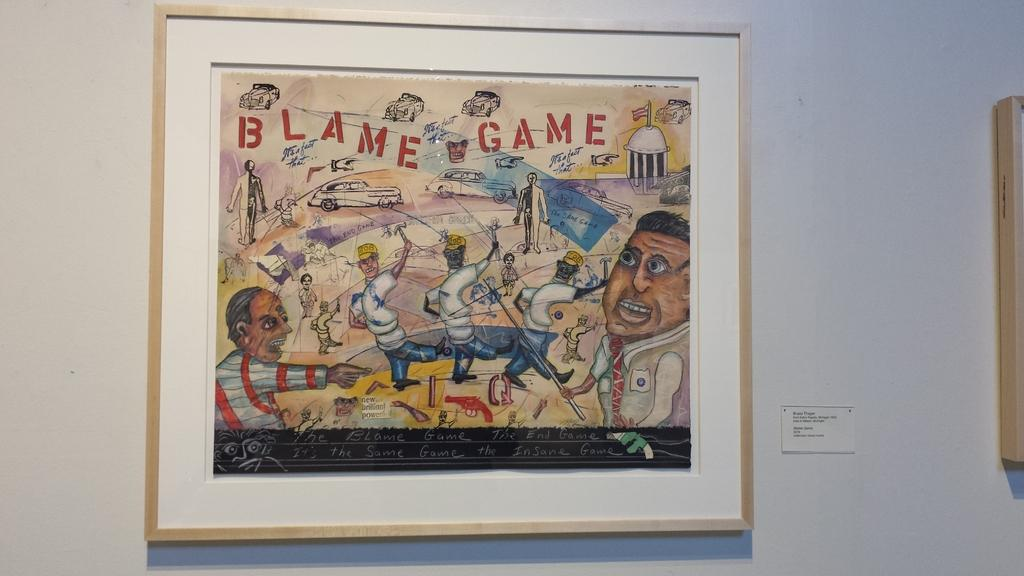What color is the wall in the image? The wall in the image is white. What is attached to the wall? There is a photo frame attached to the wall. Are there any other frames visible in the image? Yes, there is another frame visible to the right side of the image. What type of coach can be seen driving down the street in the image? There is no coach or street present in the image; it only features a white-colored wall with two photo frames. 